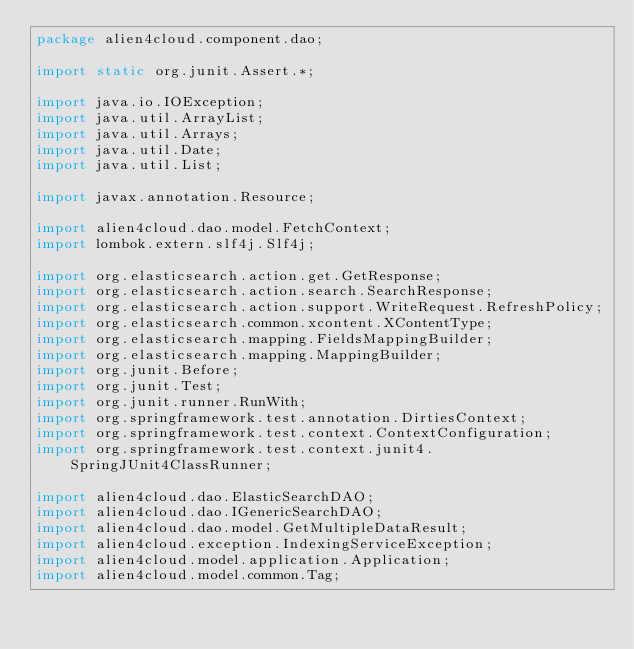Convert code to text. <code><loc_0><loc_0><loc_500><loc_500><_Java_>package alien4cloud.component.dao;

import static org.junit.Assert.*;

import java.io.IOException;
import java.util.ArrayList;
import java.util.Arrays;
import java.util.Date;
import java.util.List;

import javax.annotation.Resource;

import alien4cloud.dao.model.FetchContext;
import lombok.extern.slf4j.Slf4j;

import org.elasticsearch.action.get.GetResponse;
import org.elasticsearch.action.search.SearchResponse;
import org.elasticsearch.action.support.WriteRequest.RefreshPolicy;
import org.elasticsearch.common.xcontent.XContentType;
import org.elasticsearch.mapping.FieldsMappingBuilder;
import org.elasticsearch.mapping.MappingBuilder;
import org.junit.Before;
import org.junit.Test;
import org.junit.runner.RunWith;
import org.springframework.test.annotation.DirtiesContext;
import org.springframework.test.context.ContextConfiguration;
import org.springframework.test.context.junit4.SpringJUnit4ClassRunner;

import alien4cloud.dao.ElasticSearchDAO;
import alien4cloud.dao.IGenericSearchDAO;
import alien4cloud.dao.model.GetMultipleDataResult;
import alien4cloud.exception.IndexingServiceException;
import alien4cloud.model.application.Application;
import alien4cloud.model.common.Tag;</code> 